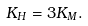<formula> <loc_0><loc_0><loc_500><loc_500>K _ { H } = 3 K _ { M } .</formula> 